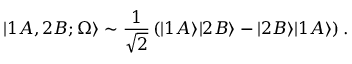<formula> <loc_0><loc_0><loc_500><loc_500>| 1 A , 2 B ; \Omega \rangle \sim \frac { 1 } { \sqrt { 2 } } \left ( | 1 A \rangle | 2 B \rangle - | 2 B \rangle | 1 A \rangle \right ) .</formula> 